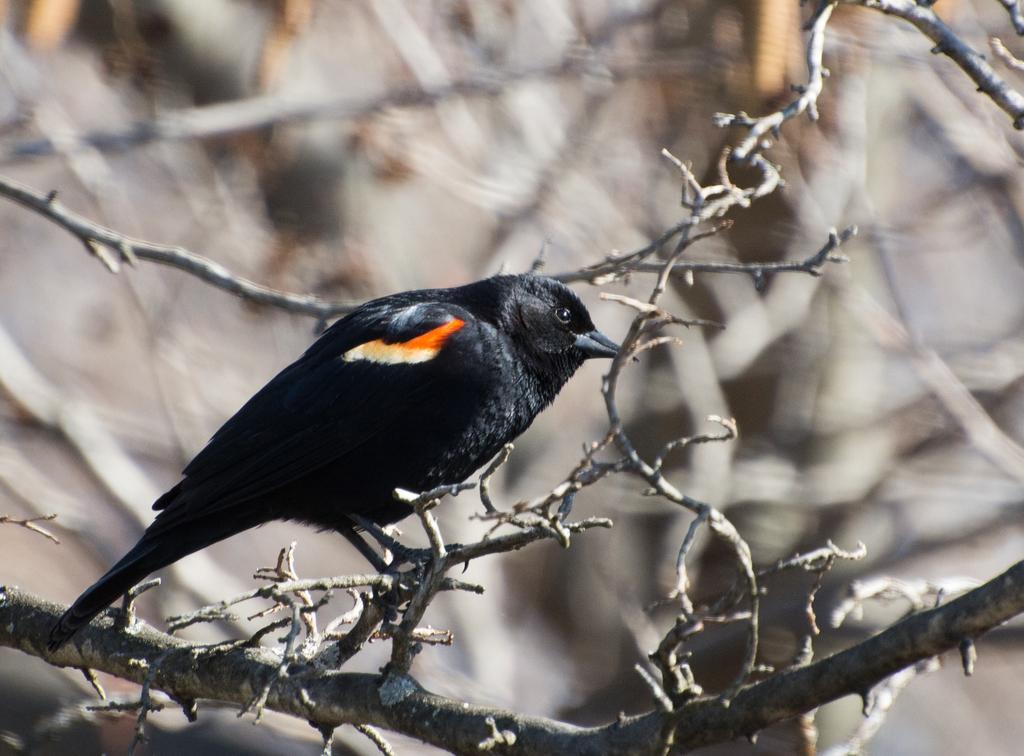Can you describe this image briefly? In this picture we can see a black bird is standing on the branch and behind the bird there is the blurred background. 